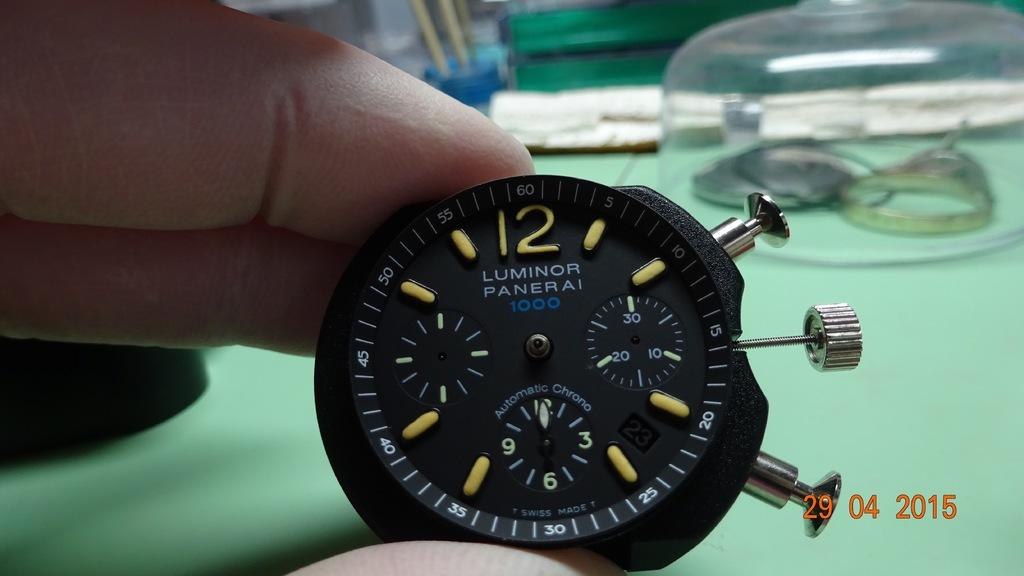<image>
Write a terse but informative summary of the picture. A picture of a watch piece that was taken on April 29, 2015. 